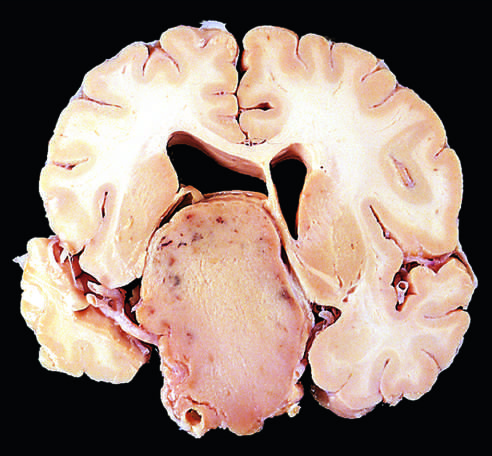do adenocarcinoma of the prostate demonstrating small glands tend to be larger at the time of diagnosis than those that secrete a hormone?
Answer the question using a single word or phrase. No 